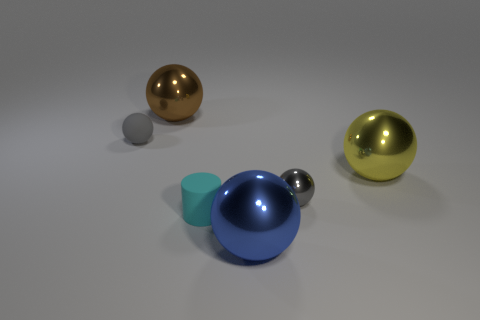Subtract all blue metal balls. How many balls are left? 4 Subtract 3 balls. How many balls are left? 2 Add 3 tiny gray balls. How many objects exist? 9 Subtract all balls. How many objects are left? 1 Subtract all gray balls. How many balls are left? 3 Subtract all gray cylinders. Subtract all purple blocks. How many cylinders are left? 1 Subtract all blue cylinders. How many brown spheres are left? 1 Subtract all small green metallic things. Subtract all yellow things. How many objects are left? 5 Add 5 yellow metal things. How many yellow metal things are left? 6 Add 5 small gray balls. How many small gray balls exist? 7 